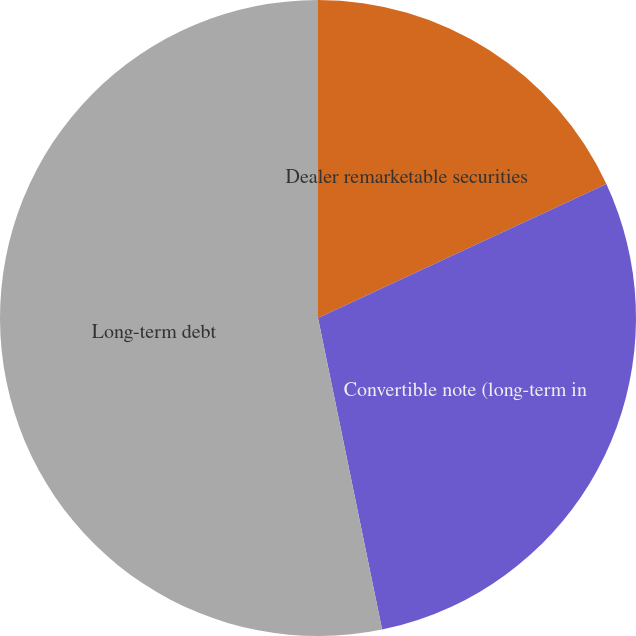<chart> <loc_0><loc_0><loc_500><loc_500><pie_chart><fcel>Dealer remarketable securities<fcel>Convertible note (long-term in<fcel>Long-term debt<nl><fcel>18.08%<fcel>28.69%<fcel>53.23%<nl></chart> 